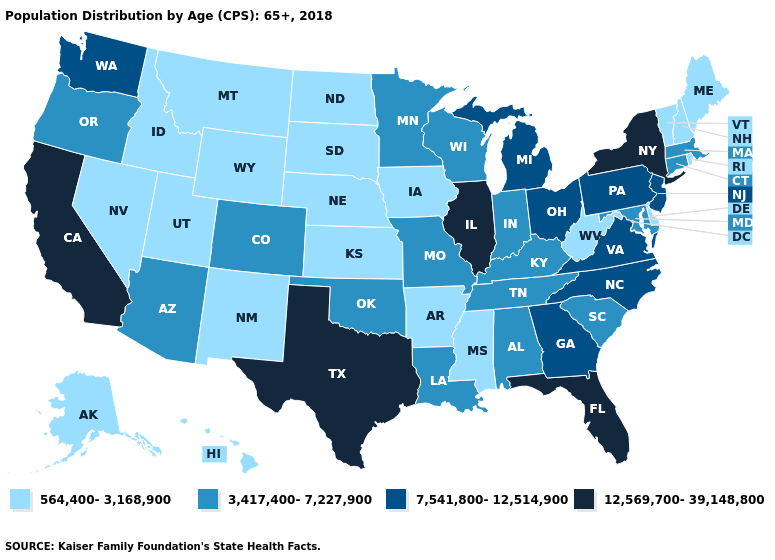What is the value of Colorado?
Answer briefly. 3,417,400-7,227,900. Among the states that border Massachusetts , does Rhode Island have the lowest value?
Quick response, please. Yes. Name the states that have a value in the range 3,417,400-7,227,900?
Quick response, please. Alabama, Arizona, Colorado, Connecticut, Indiana, Kentucky, Louisiana, Maryland, Massachusetts, Minnesota, Missouri, Oklahoma, Oregon, South Carolina, Tennessee, Wisconsin. Does Arkansas have the same value as Utah?
Answer briefly. Yes. What is the highest value in states that border Massachusetts?
Concise answer only. 12,569,700-39,148,800. Among the states that border Rhode Island , which have the lowest value?
Answer briefly. Connecticut, Massachusetts. Name the states that have a value in the range 564,400-3,168,900?
Be succinct. Alaska, Arkansas, Delaware, Hawaii, Idaho, Iowa, Kansas, Maine, Mississippi, Montana, Nebraska, Nevada, New Hampshire, New Mexico, North Dakota, Rhode Island, South Dakota, Utah, Vermont, West Virginia, Wyoming. Is the legend a continuous bar?
Give a very brief answer. No. What is the lowest value in states that border Kansas?
Quick response, please. 564,400-3,168,900. Name the states that have a value in the range 564,400-3,168,900?
Write a very short answer. Alaska, Arkansas, Delaware, Hawaii, Idaho, Iowa, Kansas, Maine, Mississippi, Montana, Nebraska, Nevada, New Hampshire, New Mexico, North Dakota, Rhode Island, South Dakota, Utah, Vermont, West Virginia, Wyoming. Name the states that have a value in the range 3,417,400-7,227,900?
Answer briefly. Alabama, Arizona, Colorado, Connecticut, Indiana, Kentucky, Louisiana, Maryland, Massachusetts, Minnesota, Missouri, Oklahoma, Oregon, South Carolina, Tennessee, Wisconsin. Does Florida have the highest value in the South?
Short answer required. Yes. What is the value of Nebraska?
Short answer required. 564,400-3,168,900. Name the states that have a value in the range 12,569,700-39,148,800?
Keep it brief. California, Florida, Illinois, New York, Texas. Does Minnesota have a higher value than Delaware?
Keep it brief. Yes. 